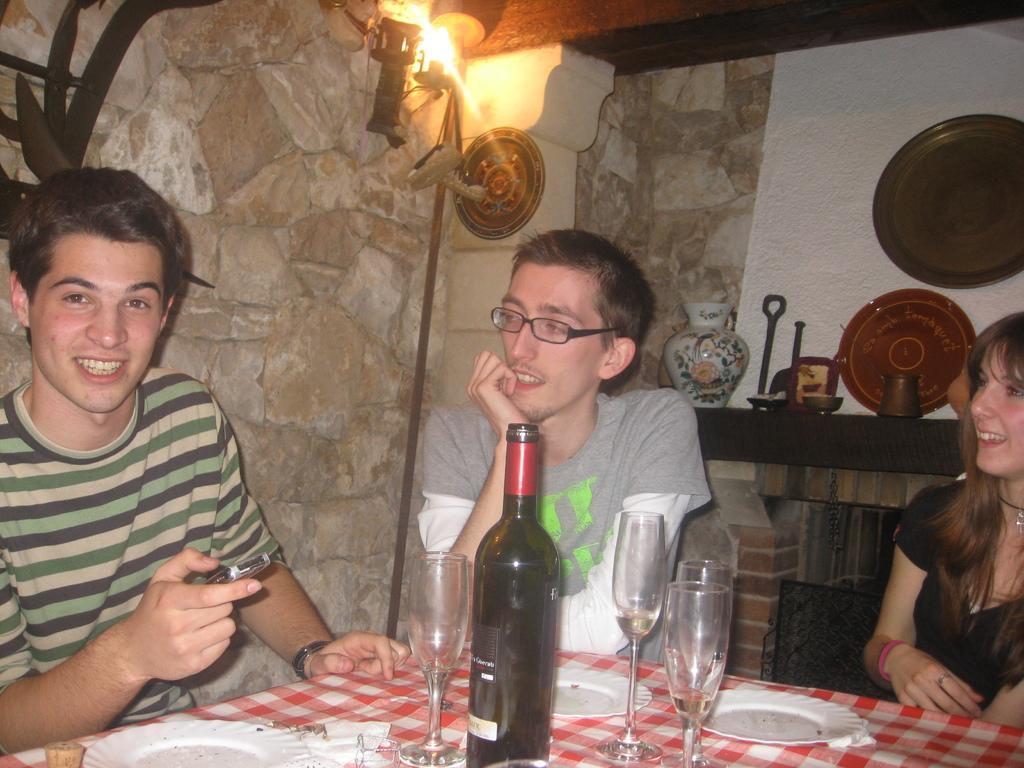Please provide a concise description of this image. In the image there are men and women sit in front of dining table with wine glass and plates on it. It seems to be dining room,In the background there are plates,jar and light over the top. 